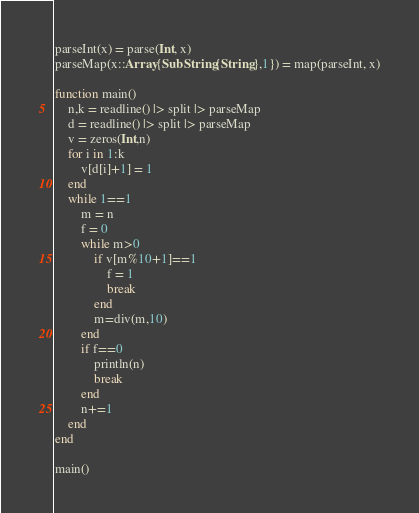<code> <loc_0><loc_0><loc_500><loc_500><_Julia_>parseInt(x) = parse(Int, x)
parseMap(x::Array{SubString{String},1}) = map(parseInt, x)

function main()
	n,k = readline() |> split |> parseMap
	d = readline() |> split |> parseMap
	v = zeros(Int,n)
	for i in 1:k
		v[d[i]+1] = 1
	end
	while 1==1
		m = n
		f = 0
		while m>0
			if v[m%10+1]==1
				f = 1
				break
			end
			m=div(m,10)
		end
		if f==0
			println(n)
			break
		end
		n+=1
	end
end

main()</code> 